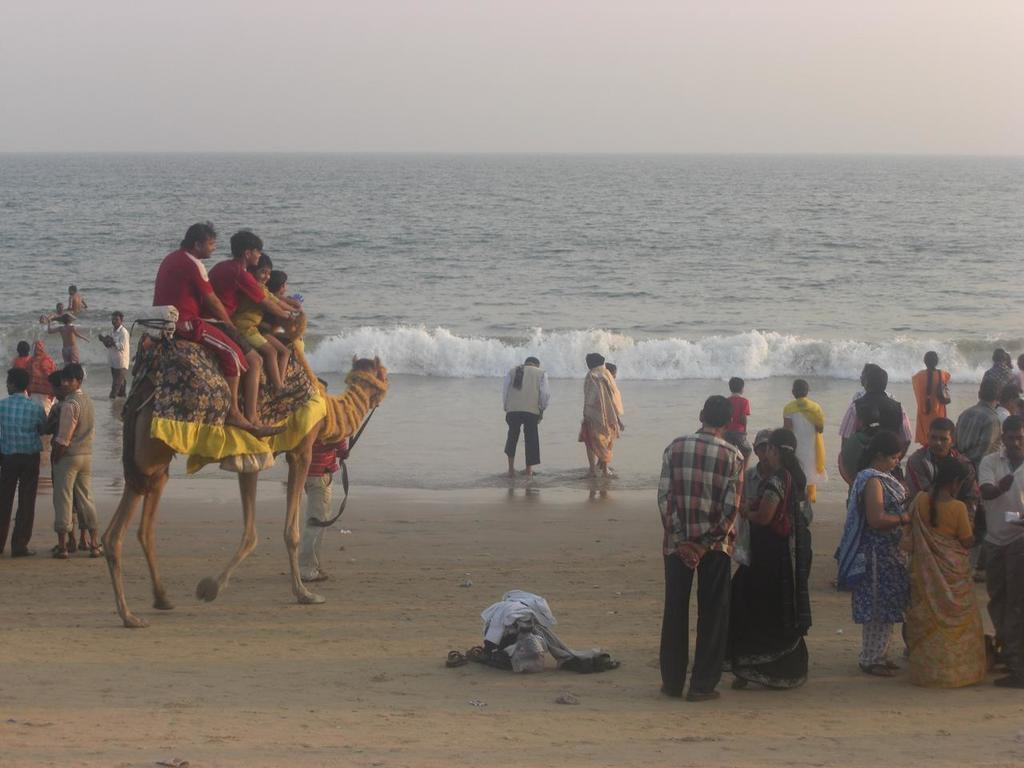What can be seen in the image involving people? There are people standing in the image. What animal is present in the image? There is a camel in the image. How are the people interacting with the camel? People are sitting on the camel. What type of water is visible in the image? There is water with waves in the image. What is visible at the top of the image? The sky is visible at the top of the image. What type of oatmeal is being served to the camel in the image? There is no oatmeal present in the image. What subject is the person teaching to the camel in the image? There is no teaching or subject being taught in the image. 